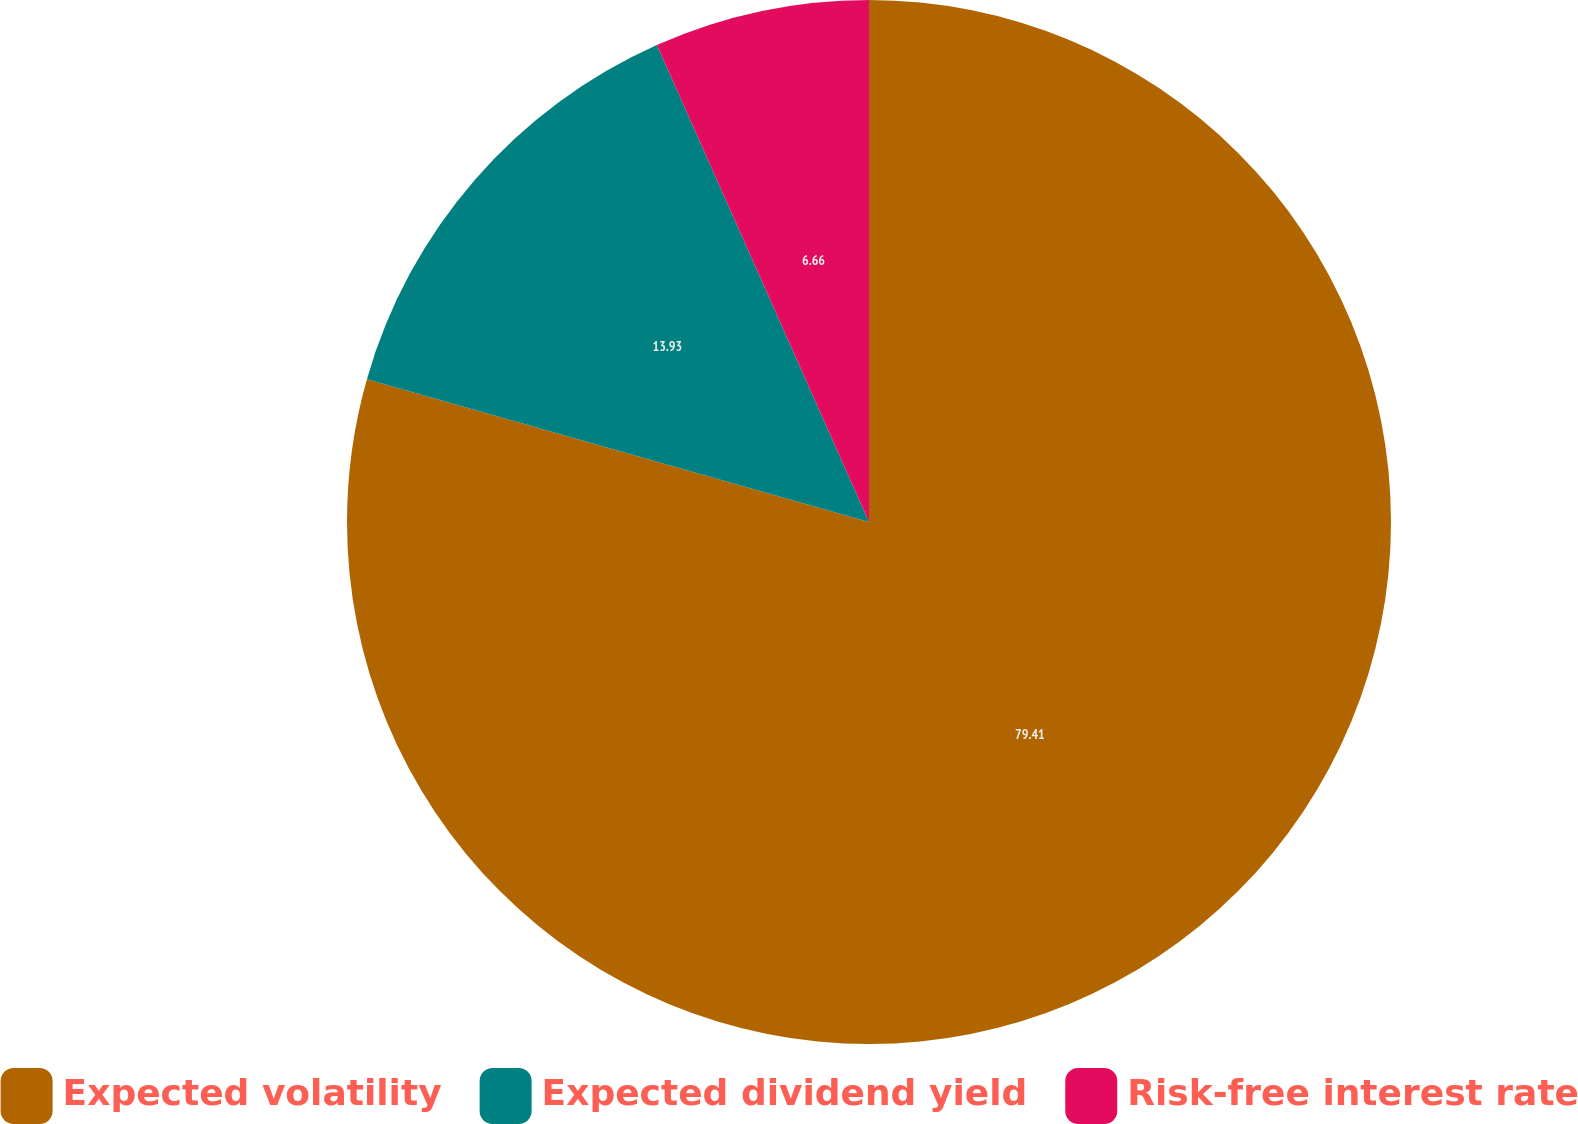Convert chart to OTSL. <chart><loc_0><loc_0><loc_500><loc_500><pie_chart><fcel>Expected volatility<fcel>Expected dividend yield<fcel>Risk-free interest rate<nl><fcel>79.41%<fcel>13.93%<fcel>6.66%<nl></chart> 